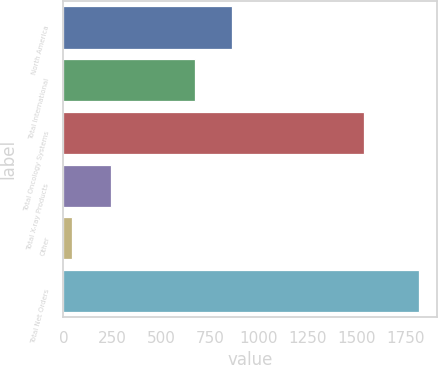Convert chart. <chart><loc_0><loc_0><loc_500><loc_500><bar_chart><fcel>North America<fcel>Total International<fcel>Total Oncology Systems<fcel>Total X-ray Products<fcel>Other<fcel>Total Net Orders<nl><fcel>861<fcel>674<fcel>1535<fcel>242<fcel>43<fcel>1820<nl></chart> 